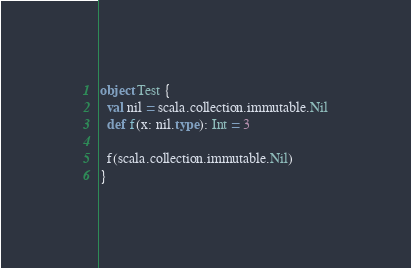Convert code to text. <code><loc_0><loc_0><loc_500><loc_500><_Scala_>object Test {
  val nil = scala.collection.immutable.Nil
  def f(x: nil.type): Int = 3

  f(scala.collection.immutable.Nil)
}
</code> 